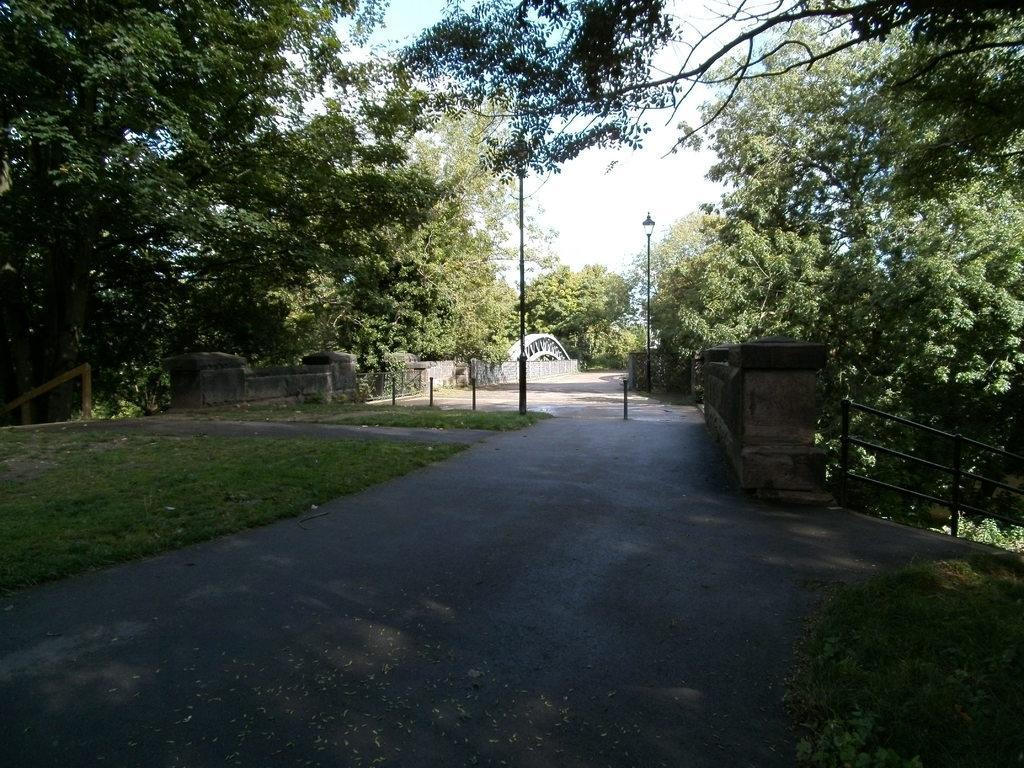In one or two sentences, can you explain what this image depicts? In this image I can see a road with a wall made up of rocks on both sides. I can see an arch over the wall on the left side. I can see some poles, some of them are holding lights. I can see grills on both sides of the image. I can see some grass on the ground. I can see some trees on both sides of the road.  